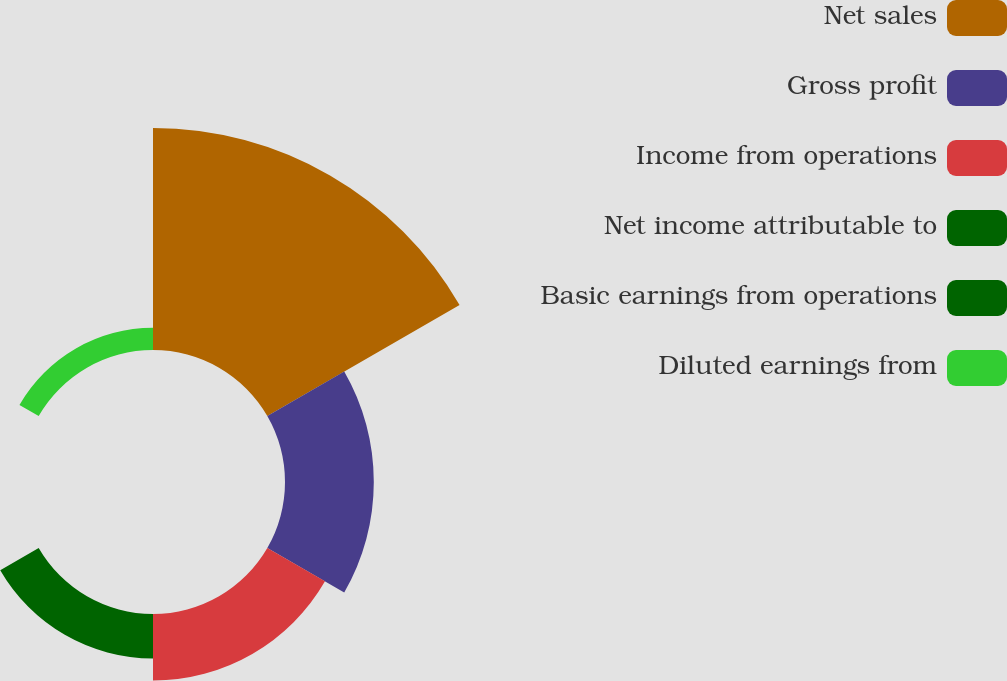Convert chart. <chart><loc_0><loc_0><loc_500><loc_500><pie_chart><fcel>Net sales<fcel>Gross profit<fcel>Income from operations<fcel>Net income attributable to<fcel>Basic earnings from operations<fcel>Diluted earnings from<nl><fcel>50.0%<fcel>20.0%<fcel>15.0%<fcel>10.0%<fcel>0.0%<fcel>5.0%<nl></chart> 